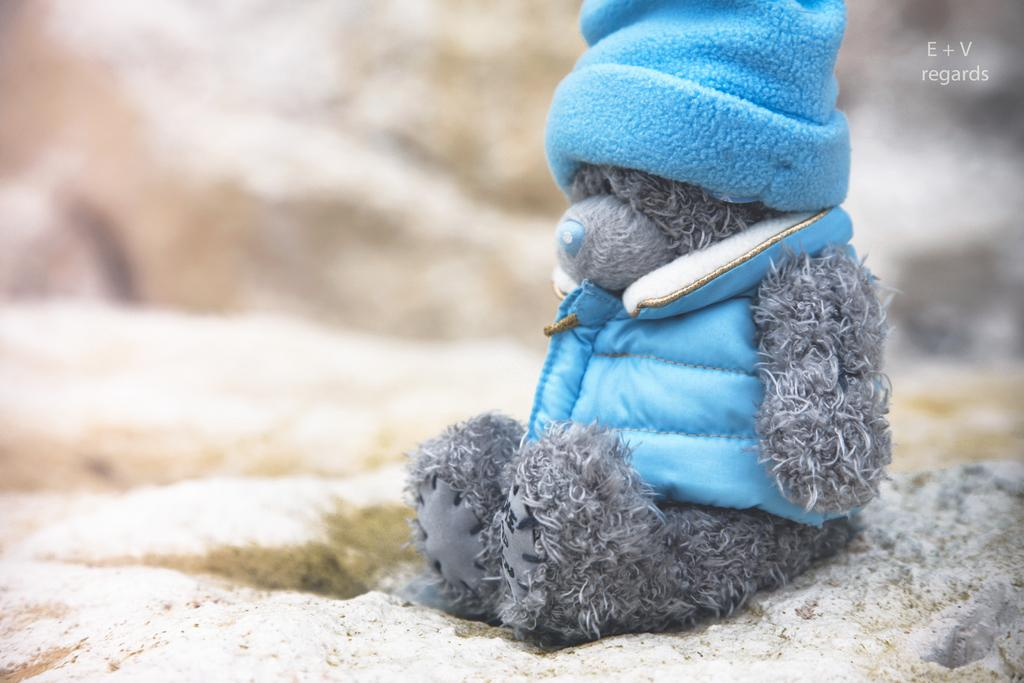What is placed on the sand in the image? There is a doll on the sand. Can you describe the background of the image? The background of the image is blurred. Is there any additional information or branding on the image? Yes, there is a watermark on the image. What type of rice is being used to create the doll's hair in the image? There is no rice present in the image, and the doll's hair is not made of rice. 